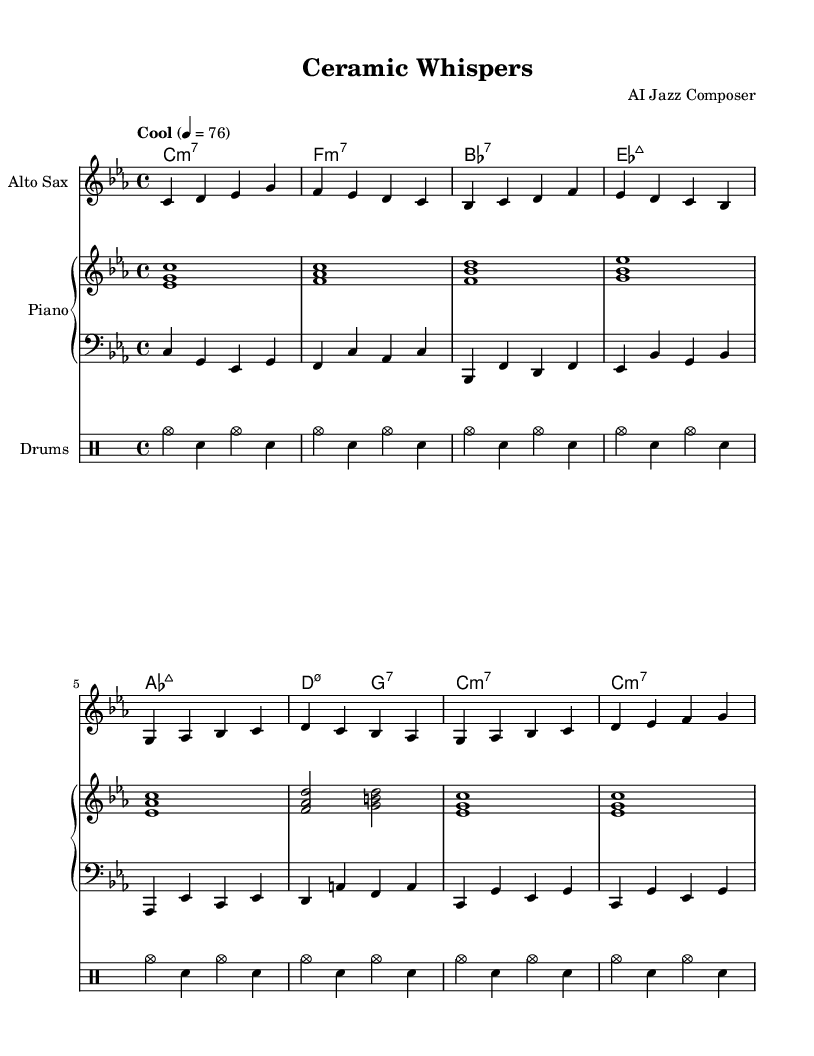What is the key signature of this music? The key signature is C minor, indicated by the presence of E flat, A flat, and B flat. In the sheet music, there are three flats listed at the beginning of the staff.
Answer: C minor What is the time signature of the piece? The time signature is 4/4, which can be seen at the beginning of the staff, indicating four beats per measure.
Answer: 4/4 What is the tempo marking for the piece? The tempo marking is "Cool," with a metronome marking of 76 beats per minute. This indicates the mood and feel intended for the performance.
Answer: Cool Which instrument plays the main melodic line? The main melodic line is played by the alto saxophone, as the corresponding staff labeled "Alto Sax" presents the melody.
Answer: Alto Sax How many measures are in the alto saxophone part? The alto saxophone part has a total of 8 measures, as counted from the beginning to the end of the melodic line displayed.
Answer: 8 What type of jazz does this piece evoke? The piece evokes "Cool" jazz, characterized by its laid-back, relaxed feel reminiscent of earthy tones, akin to stoneware pottery.
Answer: Cool jazz What chord follows the D minor 7 chord in the piano part? The chord that follows the D minor 7 chord is G7, which is shown in the chord sequence of the piano part.
Answer: G7 